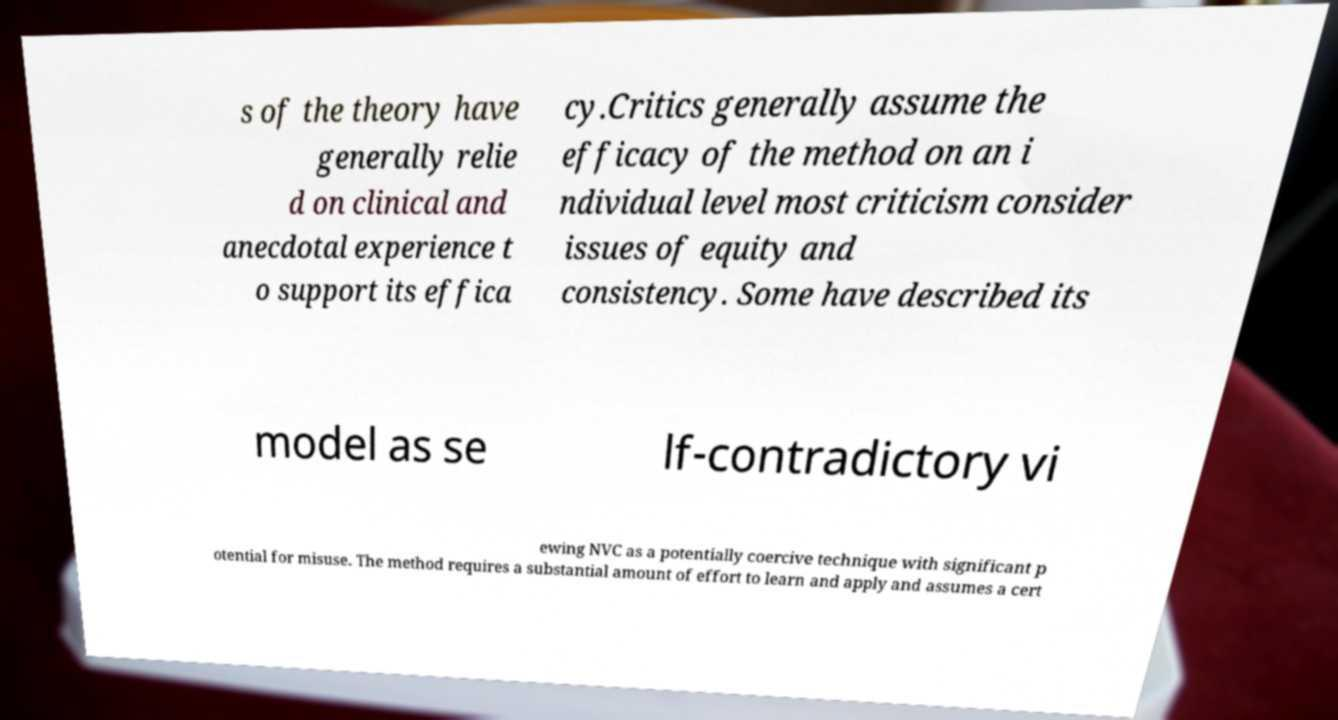Could you extract and type out the text from this image? s of the theory have generally relie d on clinical and anecdotal experience t o support its effica cy.Critics generally assume the efficacy of the method on an i ndividual level most criticism consider issues of equity and consistency. Some have described its model as se lf-contradictory vi ewing NVC as a potentially coercive technique with significant p otential for misuse. The method requires a substantial amount of effort to learn and apply and assumes a cert 